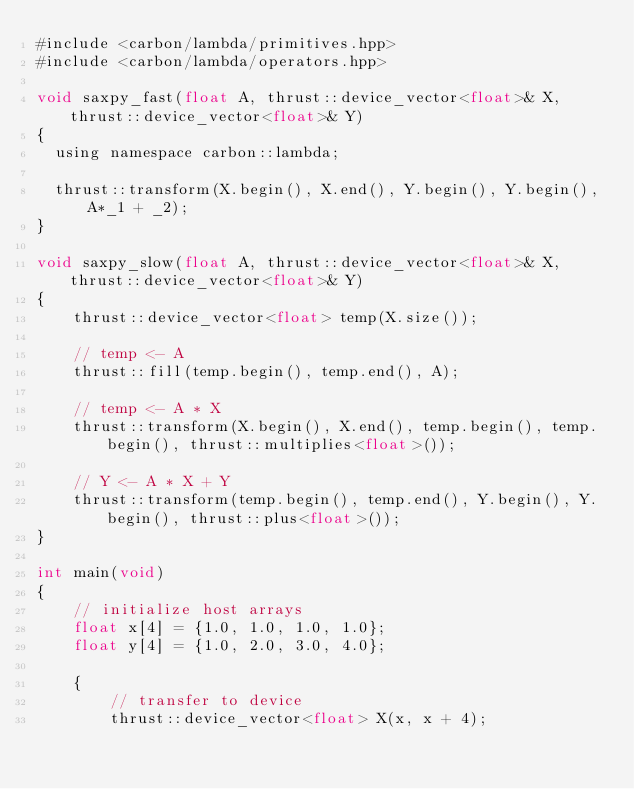Convert code to text. <code><loc_0><loc_0><loc_500><loc_500><_Cuda_>#include <carbon/lambda/primitives.hpp>
#include <carbon/lambda/operators.hpp>

void saxpy_fast(float A, thrust::device_vector<float>& X, thrust::device_vector<float>& Y)
{
  using namespace carbon::lambda;

  thrust::transform(X.begin(), X.end(), Y.begin(), Y.begin(), A*_1 + _2);
}

void saxpy_slow(float A, thrust::device_vector<float>& X, thrust::device_vector<float>& Y)
{
    thrust::device_vector<float> temp(X.size());
   
    // temp <- A
    thrust::fill(temp.begin(), temp.end(), A);
    
    // temp <- A * X
    thrust::transform(X.begin(), X.end(), temp.begin(), temp.begin(), thrust::multiplies<float>());

    // Y <- A * X + Y
    thrust::transform(temp.begin(), temp.end(), Y.begin(), Y.begin(), thrust::plus<float>());
}

int main(void)
{
    // initialize host arrays
    float x[4] = {1.0, 1.0, 1.0, 1.0};
    float y[4] = {1.0, 2.0, 3.0, 4.0};

    {
        // transfer to device
        thrust::device_vector<float> X(x, x + 4);</code> 